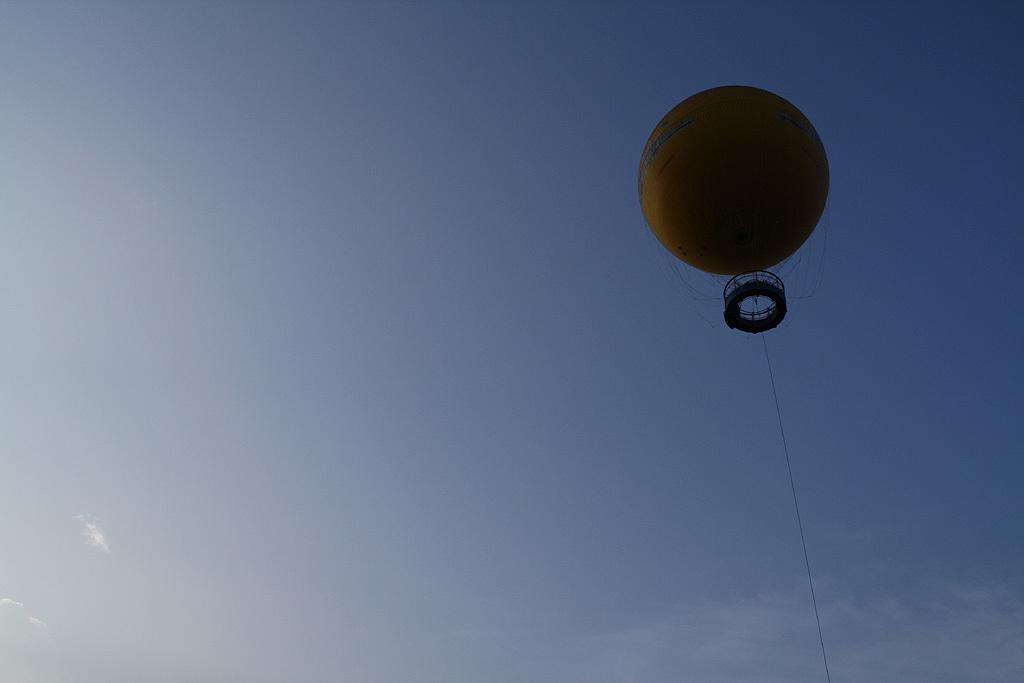What is the main subject of the image? There is a hot air balloon in the image. What can be seen in the background of the image? The sky is visible in the background of the image. Where is the library located in the image? There is no library present in the image. What type of plane can be seen flying in the image? There is no plane visible in the image; it features a hot air balloon. What is the head of the hot air balloon made of? The image does not show the head of the hot air balloon, as it is a photograph of the entire balloon. 